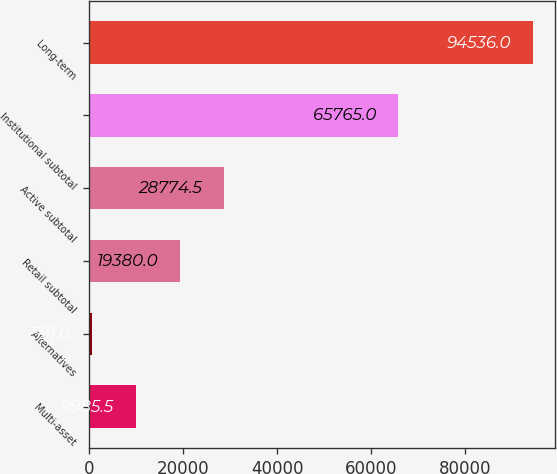Convert chart to OTSL. <chart><loc_0><loc_0><loc_500><loc_500><bar_chart><fcel>Multi-asset<fcel>Alternatives<fcel>Retail subtotal<fcel>Active subtotal<fcel>Institutional subtotal<fcel>Long-term<nl><fcel>9985.5<fcel>591<fcel>19380<fcel>28774.5<fcel>65765<fcel>94536<nl></chart> 